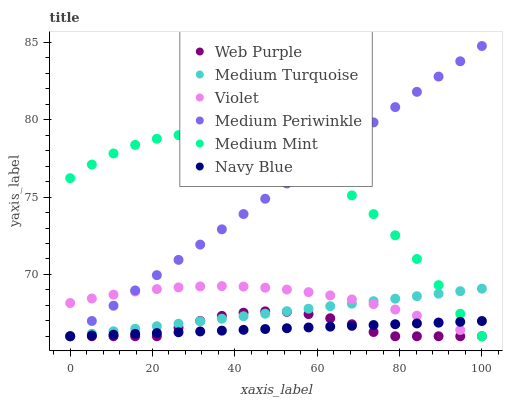Does Navy Blue have the minimum area under the curve?
Answer yes or no. Yes. Does Medium Mint have the maximum area under the curve?
Answer yes or no. Yes. Does Medium Periwinkle have the minimum area under the curve?
Answer yes or no. No. Does Medium Periwinkle have the maximum area under the curve?
Answer yes or no. No. Is Medium Turquoise the smoothest?
Answer yes or no. Yes. Is Medium Mint the roughest?
Answer yes or no. Yes. Is Navy Blue the smoothest?
Answer yes or no. No. Is Navy Blue the roughest?
Answer yes or no. No. Does Medium Mint have the lowest value?
Answer yes or no. Yes. Does Medium Periwinkle have the highest value?
Answer yes or no. Yes. Does Navy Blue have the highest value?
Answer yes or no. No. Does Medium Turquoise intersect Web Purple?
Answer yes or no. Yes. Is Medium Turquoise less than Web Purple?
Answer yes or no. No. Is Medium Turquoise greater than Web Purple?
Answer yes or no. No. 